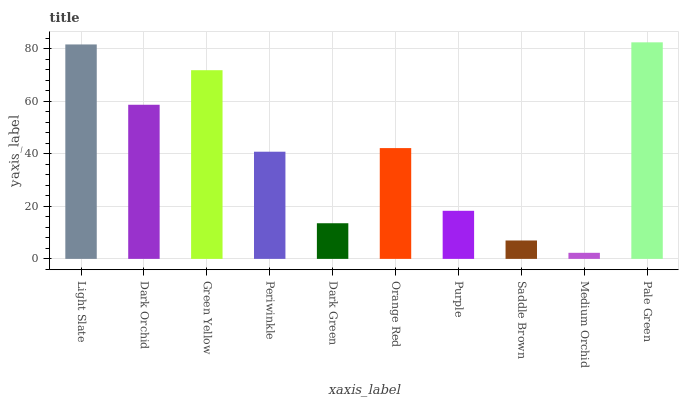Is Medium Orchid the minimum?
Answer yes or no. Yes. Is Pale Green the maximum?
Answer yes or no. Yes. Is Dark Orchid the minimum?
Answer yes or no. No. Is Dark Orchid the maximum?
Answer yes or no. No. Is Light Slate greater than Dark Orchid?
Answer yes or no. Yes. Is Dark Orchid less than Light Slate?
Answer yes or no. Yes. Is Dark Orchid greater than Light Slate?
Answer yes or no. No. Is Light Slate less than Dark Orchid?
Answer yes or no. No. Is Orange Red the high median?
Answer yes or no. Yes. Is Periwinkle the low median?
Answer yes or no. Yes. Is Pale Green the high median?
Answer yes or no. No. Is Light Slate the low median?
Answer yes or no. No. 